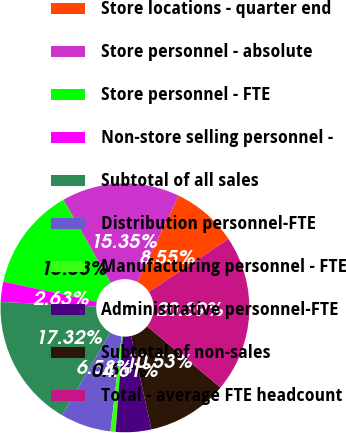Convert chart to OTSL. <chart><loc_0><loc_0><loc_500><loc_500><pie_chart><fcel>Store locations - quarter end<fcel>Store personnel - absolute<fcel>Store personnel - FTE<fcel>Non-store selling personnel -<fcel>Subtotal of all sales<fcel>Distribution personnel-FTE<fcel>Manufacturing personnel - FTE<fcel>Administrative personnel-FTE<fcel>Subtotal of non-sales<fcel>Total - average FTE headcount<nl><fcel>8.55%<fcel>15.35%<fcel>13.38%<fcel>2.63%<fcel>17.32%<fcel>6.58%<fcel>0.66%<fcel>4.61%<fcel>10.53%<fcel>20.39%<nl></chart> 